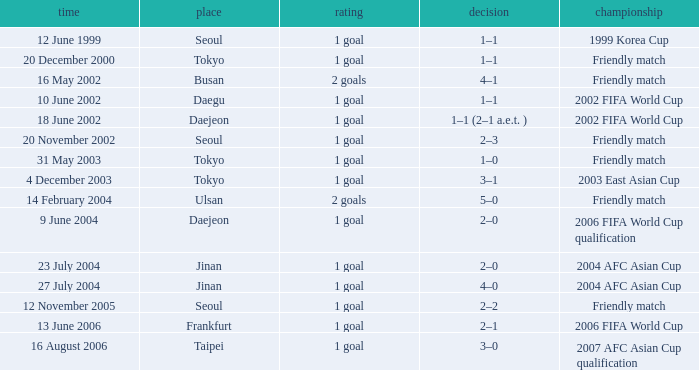What is the venue for the event on 12 November 2005? Seoul. 